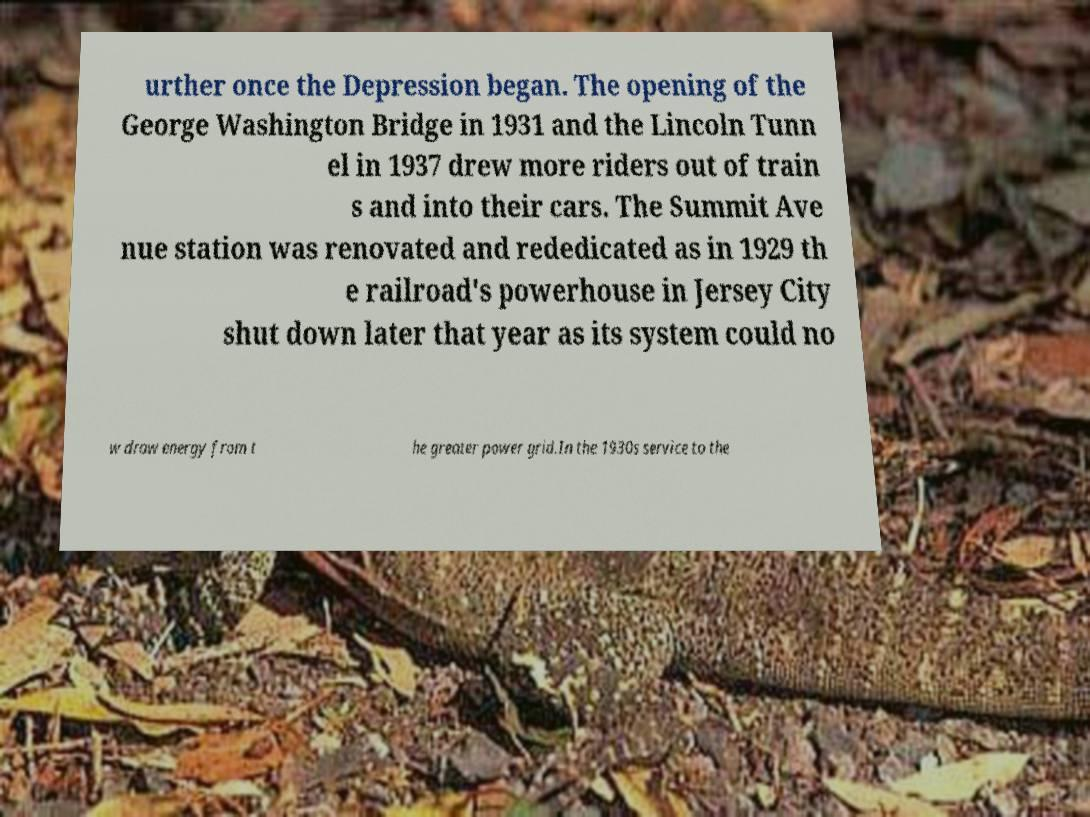Please identify and transcribe the text found in this image. urther once the Depression began. The opening of the George Washington Bridge in 1931 and the Lincoln Tunn el in 1937 drew more riders out of train s and into their cars. The Summit Ave nue station was renovated and rededicated as in 1929 th e railroad's powerhouse in Jersey City shut down later that year as its system could no w draw energy from t he greater power grid.In the 1930s service to the 